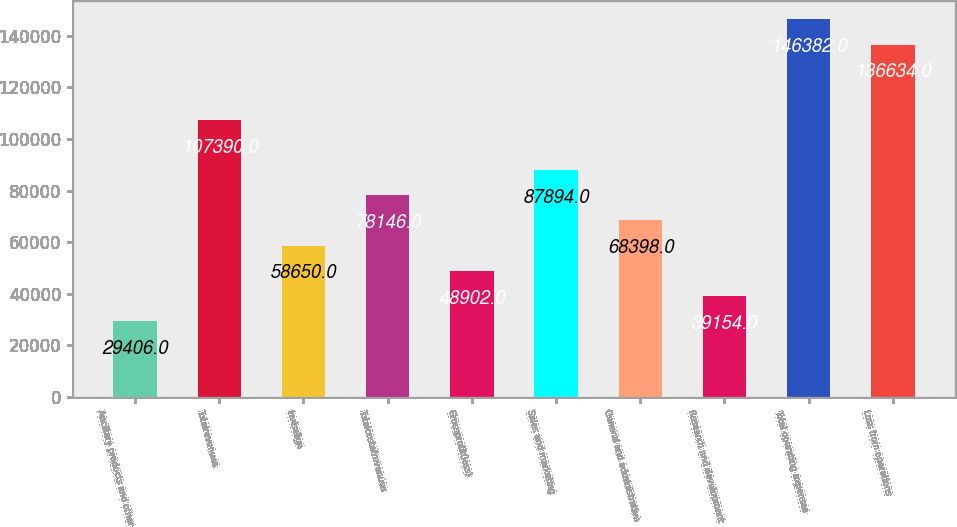Convert chart to OTSL. <chart><loc_0><loc_0><loc_500><loc_500><bar_chart><fcel>Ancillary products and other<fcel>Totalrevenues<fcel>Invisalign<fcel>Totalcostofrevenues<fcel>Grossprofit(loss)<fcel>Sales and marketing<fcel>General and administrative<fcel>Research and development<fcel>Total operating expenses<fcel>Loss from operations<nl><fcel>29406<fcel>107390<fcel>58650<fcel>78146<fcel>48902<fcel>87894<fcel>68398<fcel>39154<fcel>146382<fcel>136634<nl></chart> 